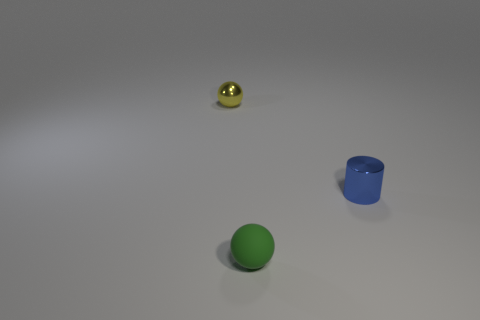The metallic thing in front of the sphere that is behind the green object is what shape?
Ensure brevity in your answer.  Cylinder. Are there any other things that have the same size as the blue thing?
Ensure brevity in your answer.  Yes. There is a tiny thing that is behind the small metal cylinder that is on the right side of the tiny ball that is in front of the yellow thing; what is its shape?
Keep it short and to the point. Sphere. What number of things are things to the left of the small green sphere or metal things that are to the left of the small green object?
Give a very brief answer. 1. There is a rubber thing; does it have the same size as the metal thing on the right side of the green matte ball?
Ensure brevity in your answer.  Yes. Are the ball that is in front of the small yellow metal sphere and the yellow thing left of the tiny green matte object made of the same material?
Offer a very short reply. No. Are there the same number of tiny yellow balls in front of the blue metallic cylinder and tiny yellow shiny balls in front of the tiny yellow metal object?
Your response must be concise. Yes. What number of other small spheres are the same color as the metallic ball?
Ensure brevity in your answer.  0. What number of matte objects are tiny spheres or blue cylinders?
Your answer should be very brief. 1. There is a metallic object that is in front of the tiny yellow metal object; is it the same shape as the object behind the cylinder?
Provide a succinct answer. No. 